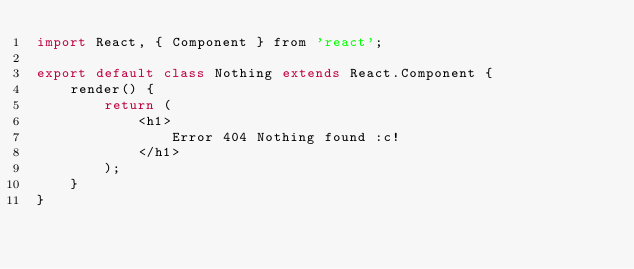Convert code to text. <code><loc_0><loc_0><loc_500><loc_500><_JavaScript_>import React, { Component } from 'react';

export default class Nothing extends React.Component {
	render() {
		return (
			<h1>
	        	Error 404 Nothing found :c!
	        </h1>
		);
	}
}</code> 